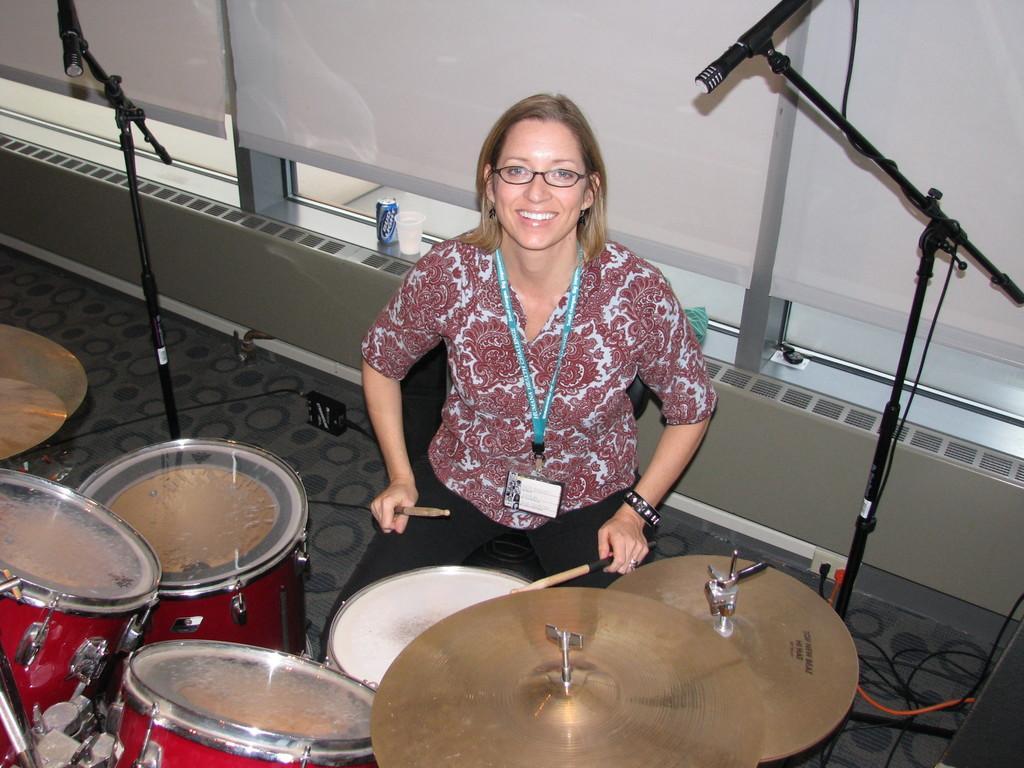In one or two sentences, can you explain what this image depicts? In this image we can see a lady sitting on chair. She is wearing specs and tag. And she is holding drum sticks. In front of her there are drums and cymbals. In the back there are mic stands. In the back there is a wall. Near to that there is a can and a glass. 